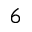Convert formula to latex. <formula><loc_0><loc_0><loc_500><loc_500>^ { 6 }</formula> 